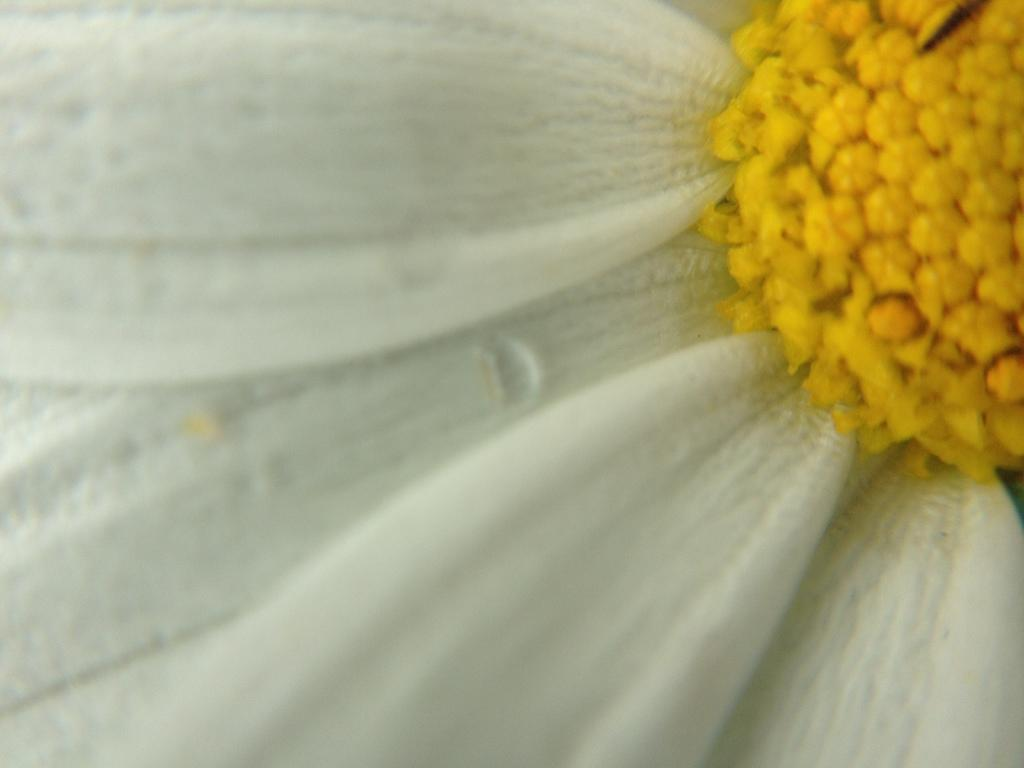What is the color of the main object in the image? There is a white object in the image. What other color can be seen in the image besides white? There are yellow objects in the image. What type of toys are being played with in the lunchroom in the image? There is no lunchroom or toys present in the image; it only features a white object and yellow objects. 